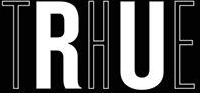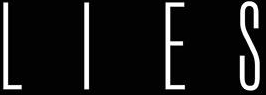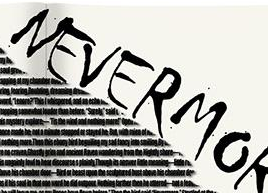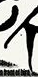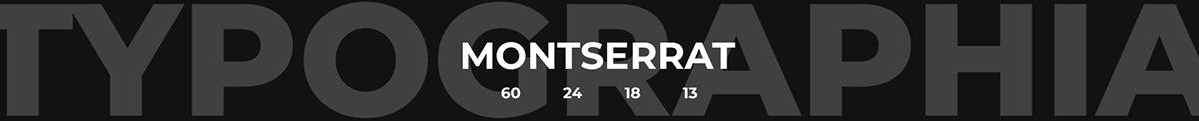Read the text from these images in sequence, separated by a semicolon. THE; LIES; NEVERMO; #; TYPOGRAPHIA 